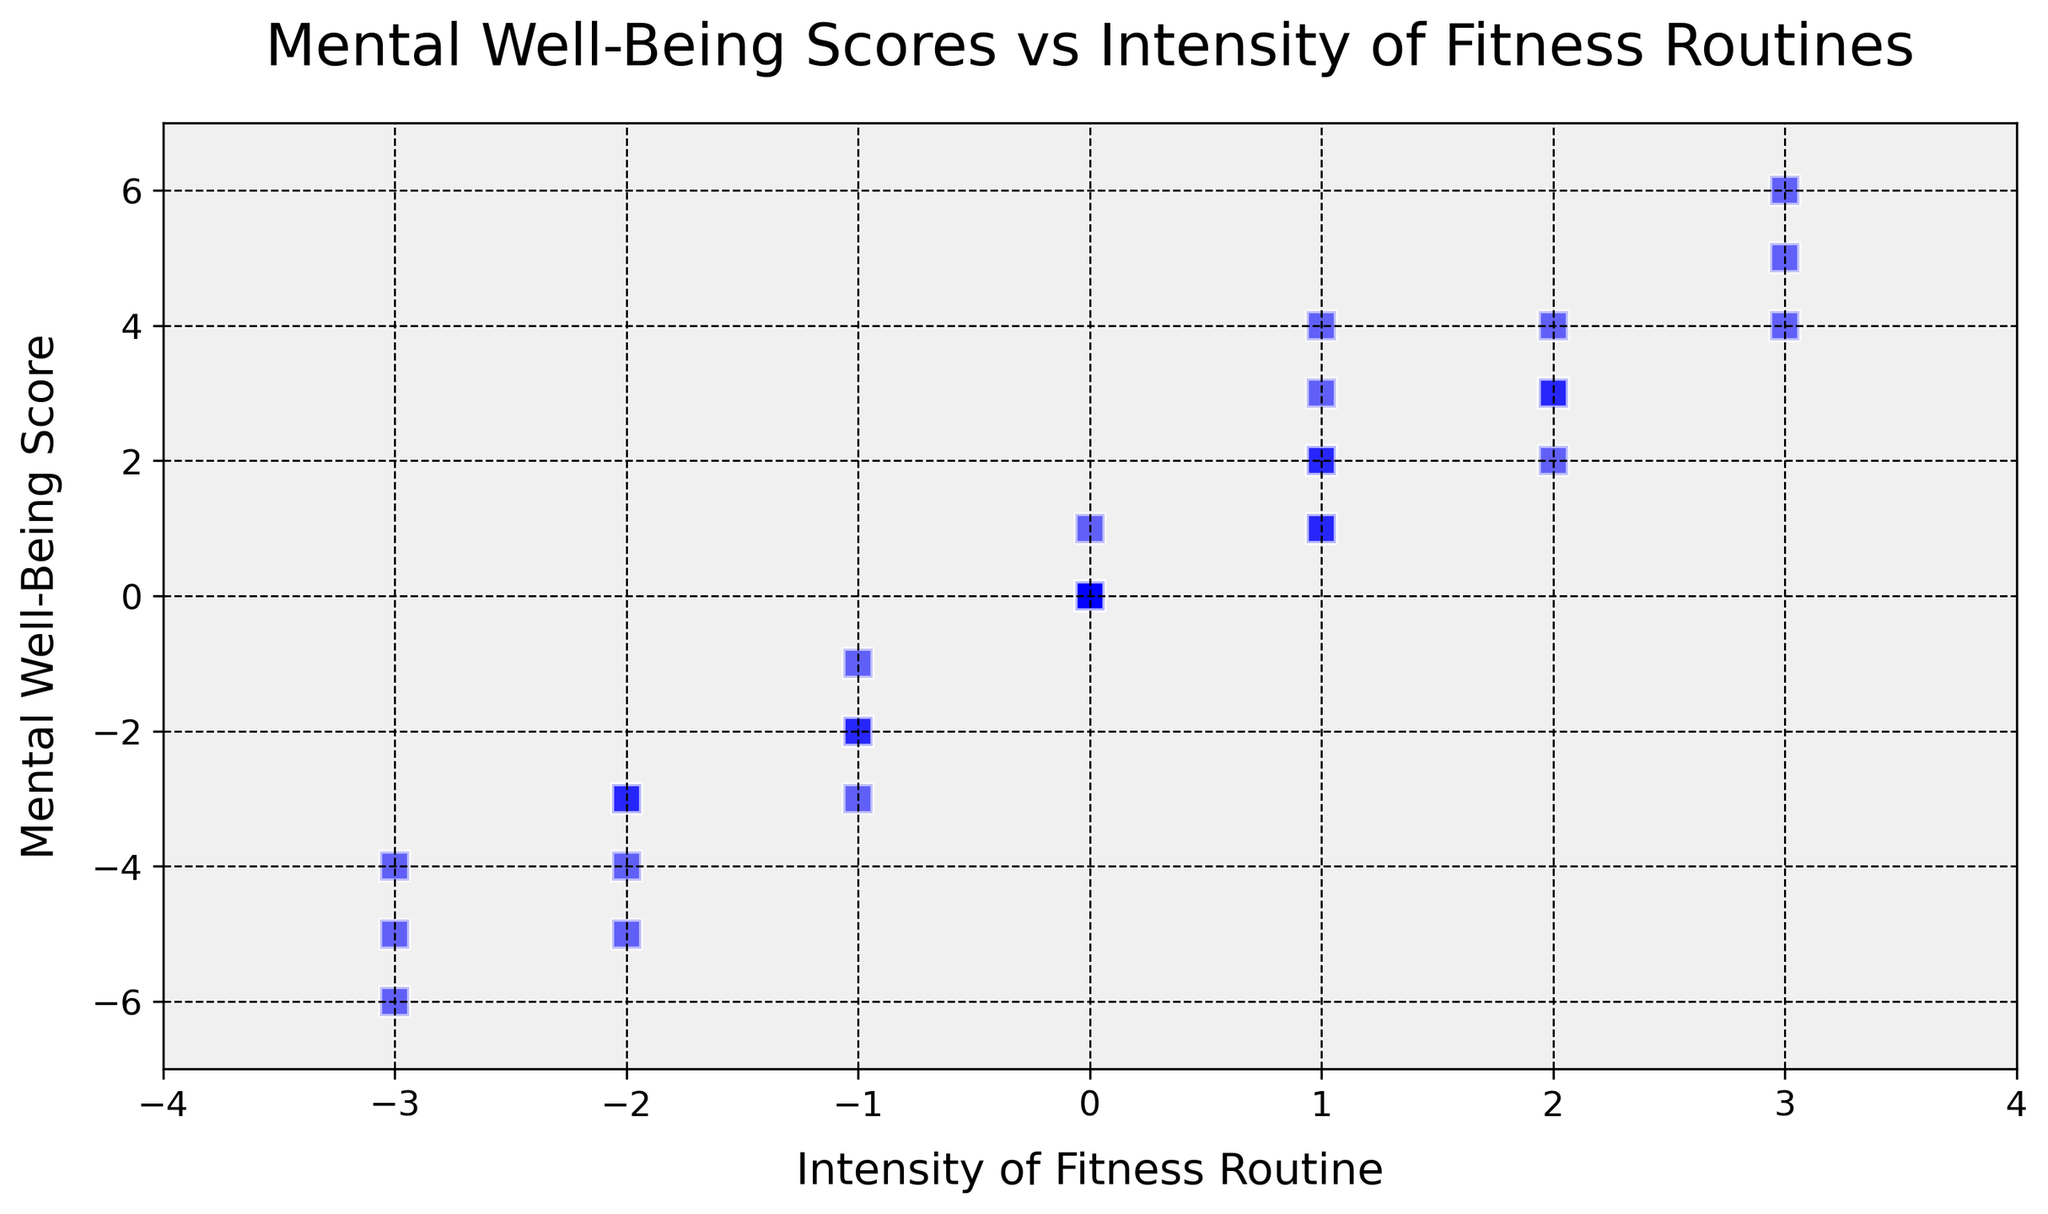What's the average intensity of all data points? Add all intensity values and divide by the number of data points: (-3 - 2 - 1 + 0 + 1 + 2 + 3 - 2 - 1 + 0 + 1 + 2 - 3 - 1 + 0 + 1 + 2 + 3 - 3 - 2 + 0 + 1 + 3 - 2 + 0 + 1 - 1 + 0 + 2 + 1). The sum is -1. There are 30 points, so -1/30 ≈ -0.033
Answer: -0.033 What is the trend between intensity and mental well-being scores? Observing the scatter plot, we can see a general upward trend, indicating a positive correlation between higher intensity and higher mental well-being scores
Answer: Positive correlation How many data points have a negative mental well-being score with positive intensity? There are no data points in the figure with positive intensity and a negative mental well-being score
Answer: 0 What is the difference between the highest and lowest mental well-being scores? The highest score is 6 and the lowest score is -6. The difference is 6 - (-6) = 12
Answer: 12 Which intensity value has the most varied mental well-being score range? Intensity of 1 varies from 1 to 4, giving a range of 3. Other intensities do not exhibit such a wide range
Answer: 1 How many data points lie on the (0,0) coordinate? By examining the scatter plot, there are 5 points at the coordinate (0,0)
Answer: 5 What is the median mental well-being score of the data points with an intensity of 1? The scores are 1, 2, 3, and 4. The median score is (2 + 3) / 2 = 2.5
Answer: 2.5 What's the average mental well-being score for positive intensity values? Sum the scores for positive intensities (1, 3, 2, 4, 6, 1, 4) which adds up to 21 and there are 7 such points. 21/7 = 3
Answer: 3 How many data points have an intensity greater than or equal to 2? The points for 2 and 3 intensities are counted: 2,3,2,4,3,4,6,3. A total of 8 points
Answer: 8 Which intensity value has the highest corresponding mental well-being score on average? Average scores for each intensity: -3: -5, -4, -6 = -5; -2: -4, -3, -5 = -4; -1: -2, -1, -2, -3 = -2; 0: 0,0,1,0,0 = 0.2; 1: 1,2,3,2, 4 = 2.4; 2: 3,4,2,3 = 3; 3: 5,4,6 = 5. Average for 3 is highest at 5
Answer: 3 